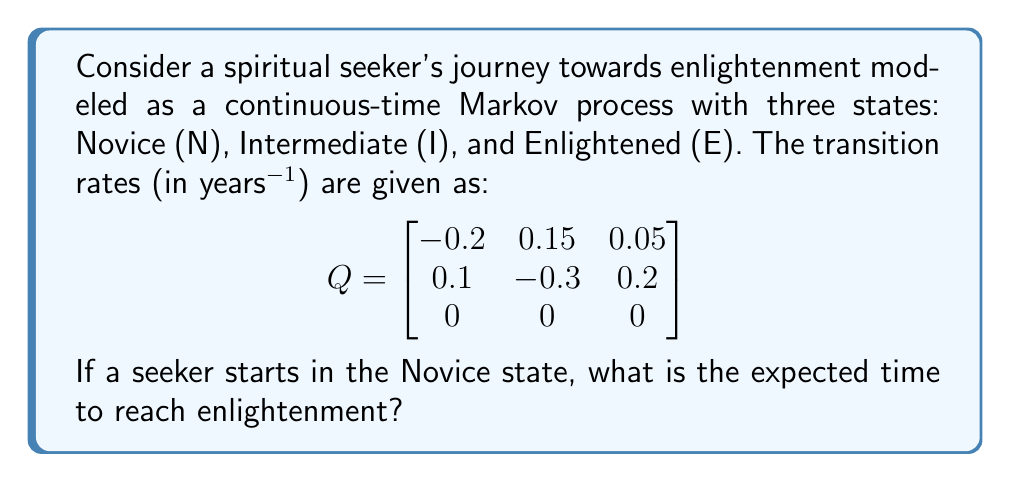Help me with this question. To solve this problem, we'll use the concept of mean first passage times in continuous-time Markov processes.

Step 1: Identify the transient states and the absorbing state.
Transient states: N (Novice) and I (Intermediate)
Absorbing state: E (Enlightened)

Step 2: Extract the submatrix Q' containing only the transient states.
$$ Q' = \begin{bmatrix}
-0.2 & 0.15 \\
0.1 & -0.3
\end{bmatrix} $$

Step 3: Calculate the fundamental matrix N = -Q'^(-1).
$$ N = -\begin{bmatrix}
-0.2 & 0.15 \\
0.1 & -0.3
\end{bmatrix}^{-1} = \begin{bmatrix}
6.25 & 3.125 \\
2.083 & 4.167
\end{bmatrix} $$

Step 4: The expected time to absorption (enlightenment) from each transient state is given by Ne, where e is a column vector of ones.
$$ \begin{bmatrix}
6.25 & 3.125 \\
2.083 & 4.167
\end{bmatrix} \begin{bmatrix}
1 \\
1
\end{bmatrix} = \begin{bmatrix}
9.375 \\
6.25
\end{bmatrix} $$

Step 5: Since the seeker starts in the Novice state, we take the first element of the resulting vector, which is 9.375 years.
Answer: 9.375 years 